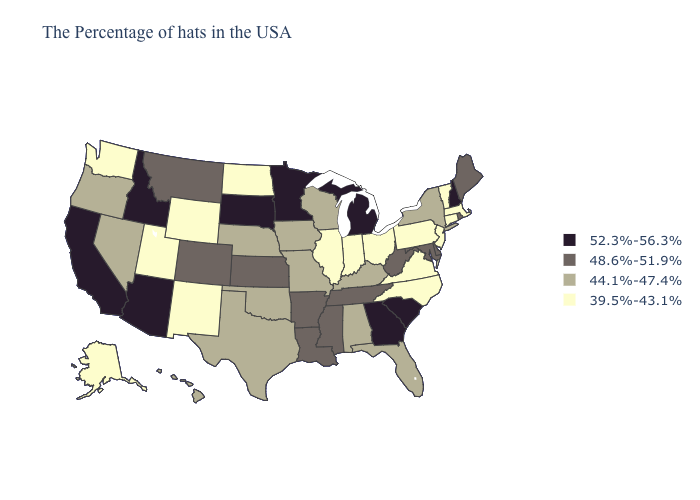Does Wyoming have the same value as Utah?
Answer briefly. Yes. Which states have the lowest value in the MidWest?
Be succinct. Ohio, Indiana, Illinois, North Dakota. Name the states that have a value in the range 52.3%-56.3%?
Quick response, please. New Hampshire, South Carolina, Georgia, Michigan, Minnesota, South Dakota, Arizona, Idaho, California. Does California have the highest value in the USA?
Write a very short answer. Yes. What is the lowest value in the USA?
Keep it brief. 39.5%-43.1%. Name the states that have a value in the range 39.5%-43.1%?
Quick response, please. Massachusetts, Vermont, Connecticut, New Jersey, Pennsylvania, Virginia, North Carolina, Ohio, Indiana, Illinois, North Dakota, Wyoming, New Mexico, Utah, Washington, Alaska. Does the first symbol in the legend represent the smallest category?
Keep it brief. No. Among the states that border Ohio , which have the highest value?
Keep it brief. Michigan. Does the map have missing data?
Be succinct. No. What is the highest value in the West ?
Keep it brief. 52.3%-56.3%. What is the value of Georgia?
Answer briefly. 52.3%-56.3%. Name the states that have a value in the range 44.1%-47.4%?
Answer briefly. New York, Florida, Kentucky, Alabama, Wisconsin, Missouri, Iowa, Nebraska, Oklahoma, Texas, Nevada, Oregon, Hawaii. What is the lowest value in states that border West Virginia?
Quick response, please. 39.5%-43.1%. Which states have the lowest value in the Northeast?
Short answer required. Massachusetts, Vermont, Connecticut, New Jersey, Pennsylvania. 